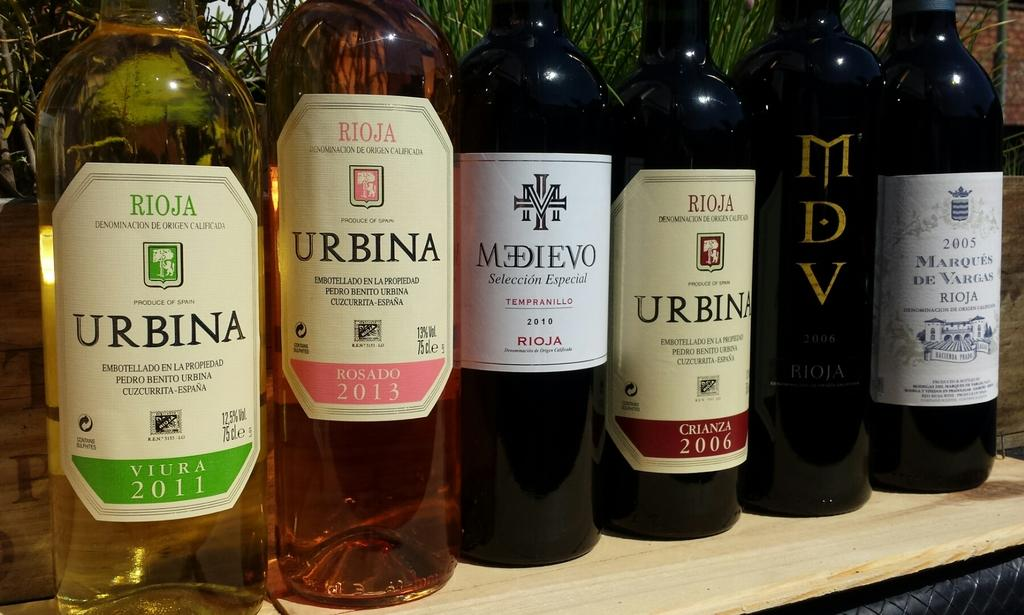<image>
Relay a brief, clear account of the picture shown. A bunch of Urbina beverages are on display. 